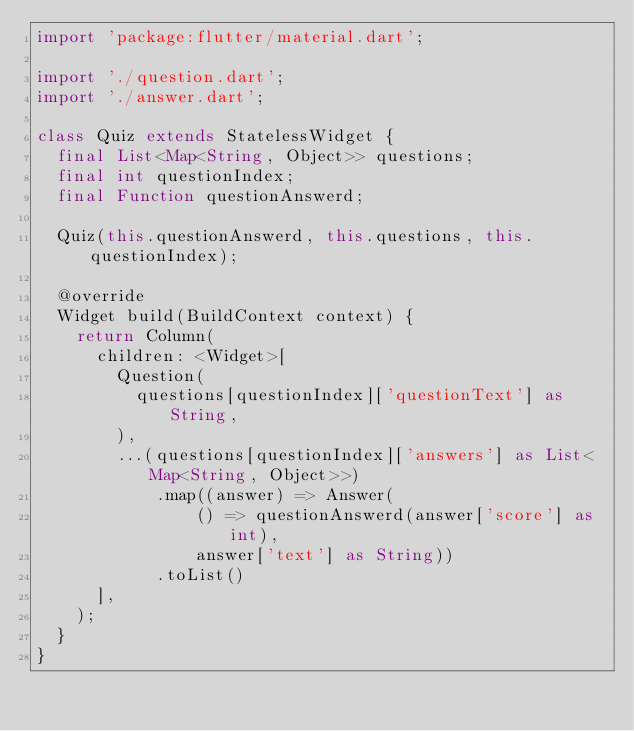Convert code to text. <code><loc_0><loc_0><loc_500><loc_500><_Dart_>import 'package:flutter/material.dart';

import './question.dart';
import './answer.dart';

class Quiz extends StatelessWidget {
  final List<Map<String, Object>> questions;
  final int questionIndex;
  final Function questionAnswerd;

  Quiz(this.questionAnswerd, this.questions, this.questionIndex);

  @override
  Widget build(BuildContext context) {
    return Column(
      children: <Widget>[
        Question(
          questions[questionIndex]['questionText'] as String,
        ),
        ...(questions[questionIndex]['answers'] as List<Map<String, Object>>)
            .map((answer) => Answer(
                () => questionAnswerd(answer['score'] as int),
                answer['text'] as String))
            .toList()
      ],
    );
  }
}
</code> 